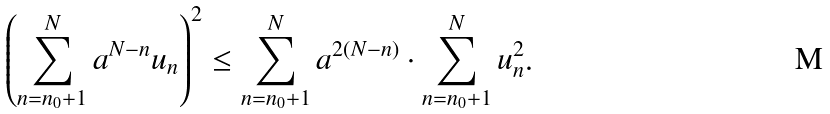Convert formula to latex. <formula><loc_0><loc_0><loc_500><loc_500>\left ( \sum _ { n = n _ { 0 } + 1 } ^ { N } a ^ { N - n } u _ { n } \right ) ^ { 2 } \leq \sum _ { n = n _ { 0 } + 1 } ^ { N } a ^ { 2 ( N - n ) } \cdot \sum _ { n = n _ { 0 } + 1 } ^ { N } u _ { n } ^ { 2 } .</formula> 